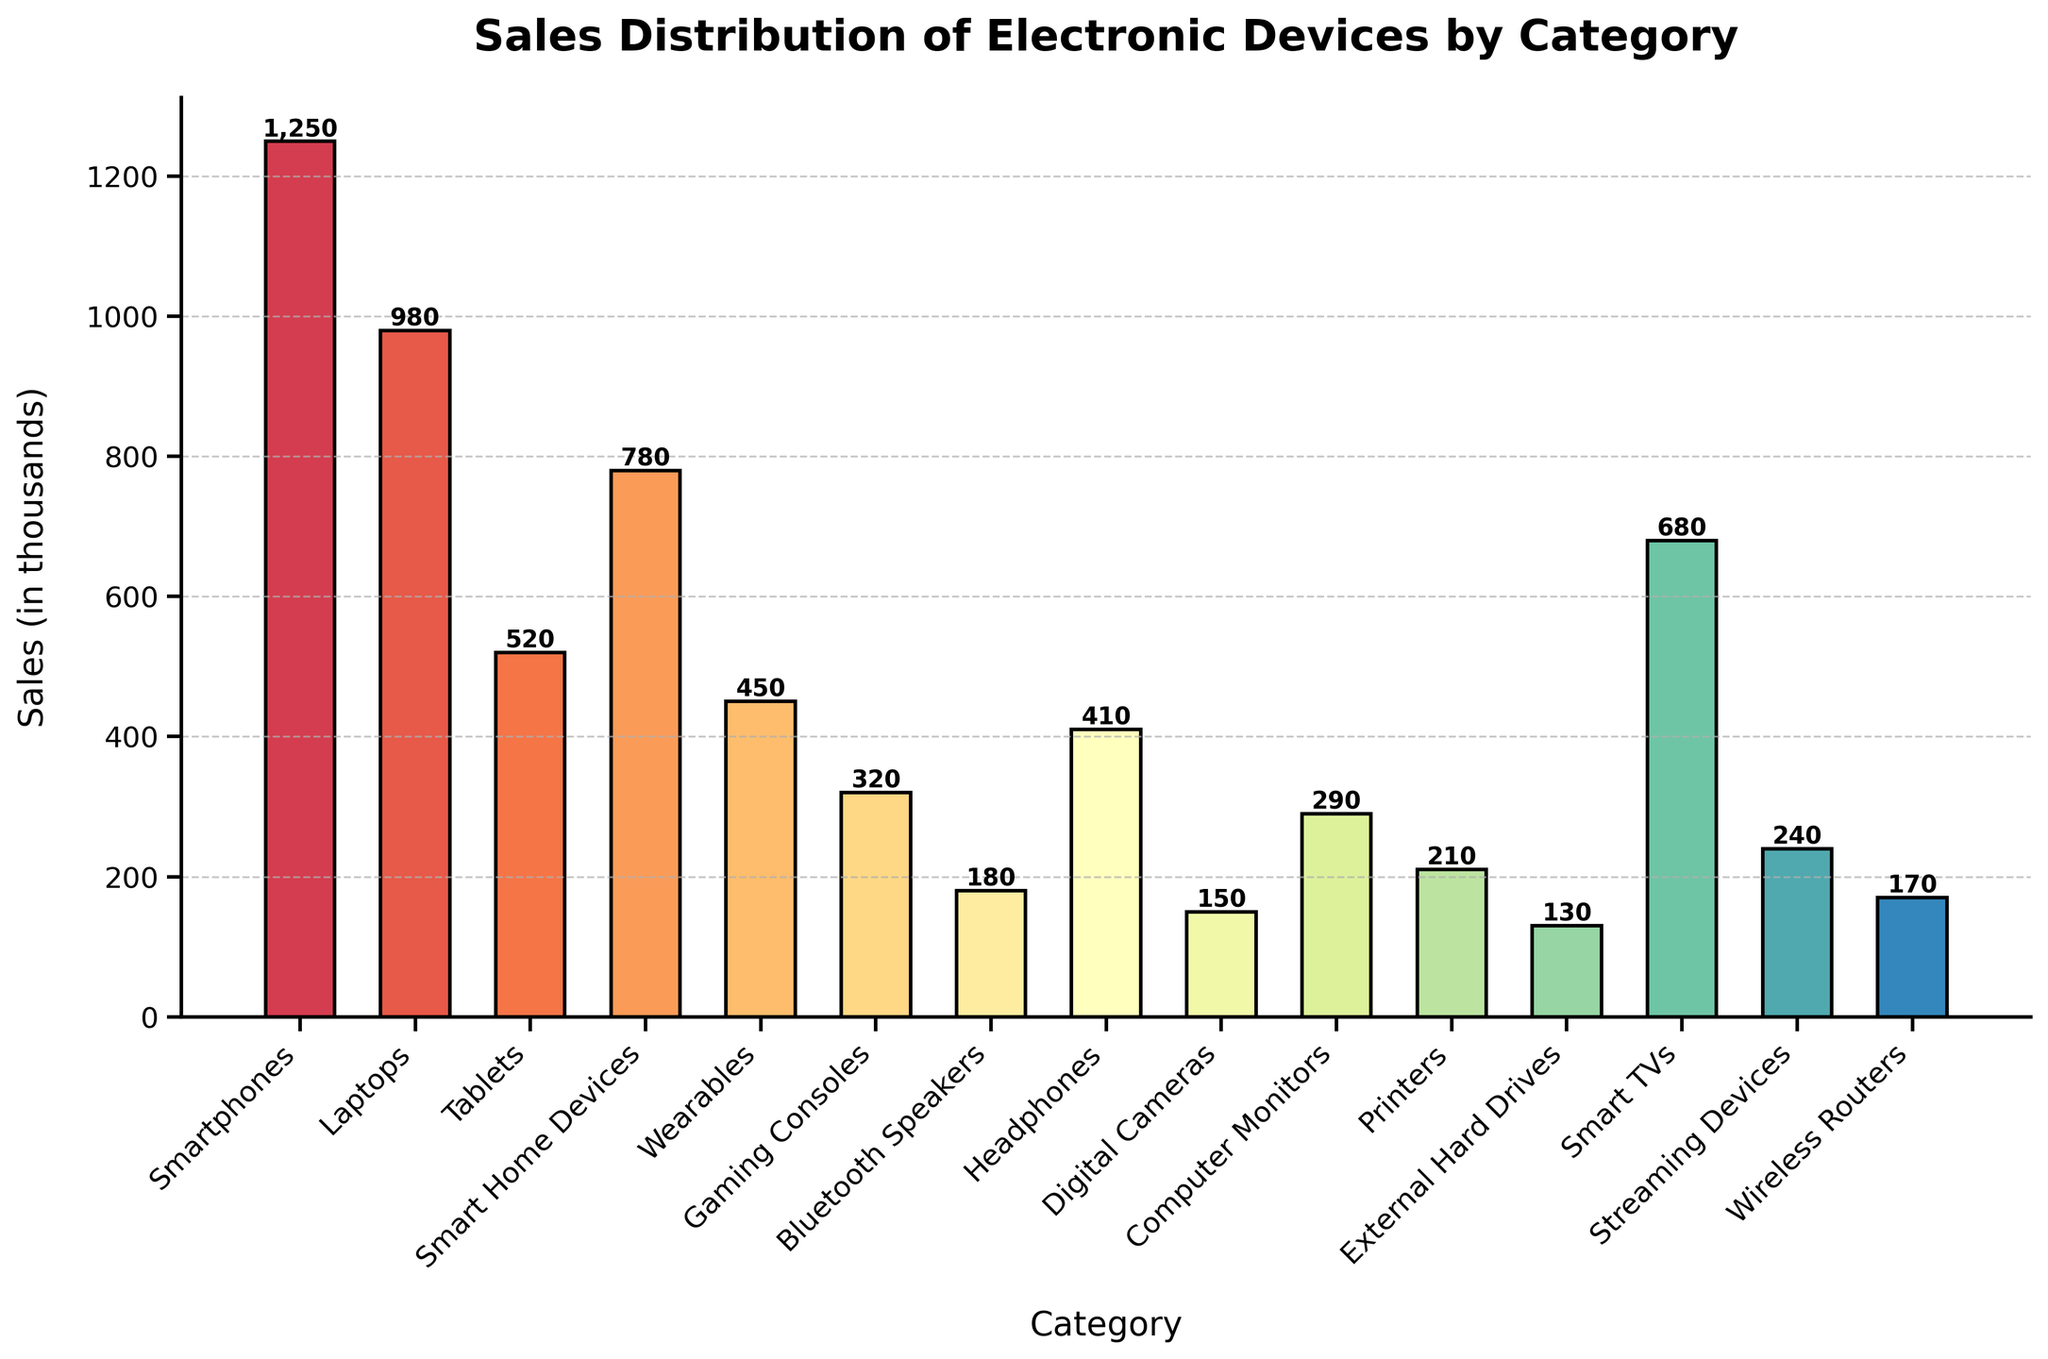Which category has the highest sales? The bar with the tallest height represents the highest sales. From the figure, the 'Smartphones' category has the tallest bar.
Answer: Smartphones Which category has the lowest sales? The bar with the shortest height represents the lowest sales. The 'Digital Cameras' category has the shortest bar.
Answer: Digital Cameras What is the total sales for Smart TVs, Streaming Devices, and Wireless Routers combined? Add the sales values of these three categories: 680 (Smart TVs) + 240 (Streaming Devices) + 170 (Wireless Routers) = 1,090.
Answer: 1,090 How much more did Smart Home Devices sell compared to Wearables? Subtract the sales of Wearables from the sales of Smart Home Devices: 780 (Smart Home Devices) - 450 (Wearables) = 330.
Answer: 330 Which categories have sales greater than 500 thousand? Identify bars with heights greater than 500. The categories with sales greater than 500 are 'Smartphones', 'Laptops', 'Smart Home Devices', 'Smart TVs', and 'Tablets'.
Answer: Smartphones, Laptops, Smart Home Devices, Smart TVs, Tablets What is the average sales across all categories? Sum all sales and divide by the number of categories: (1250 + 980 + 520 + 780 + 450 + 320 + 180 + 410 + 150 + 290 + 210 + 130 + 680 + 240 + 170) / 15 = 6,760 / 15 = 450.67.
Answer: 450.67 Between Tablets and Laptops, which category has higher sales and by how much? Laptops have sales of 980 and Tablets have 520. Subtract the sales of Tablets from Laptops: 980 - 520 = 460.
Answer: Laptops, 460 How do the sales of Bluetooth Speakers compare with those of Headphones? Calculate the difference: 410 (Headphones) - 180 (Bluetooth Speakers) = 230. Headphones have higher sales by 230.
Answer: Headphones, 230 Which category is the median in terms of sales? Sort the categories by sales. The 8th category is the median: (sorted list: 130, 150, 170, 180, 210, 240, 290, 320, 410, 450, 520, 680, 780, 980, 1250). The median category is 'Gaming Consoles' with sales of 320.
Answer: Gaming Consoles 